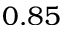<formula> <loc_0><loc_0><loc_500><loc_500>0 . 8 5</formula> 